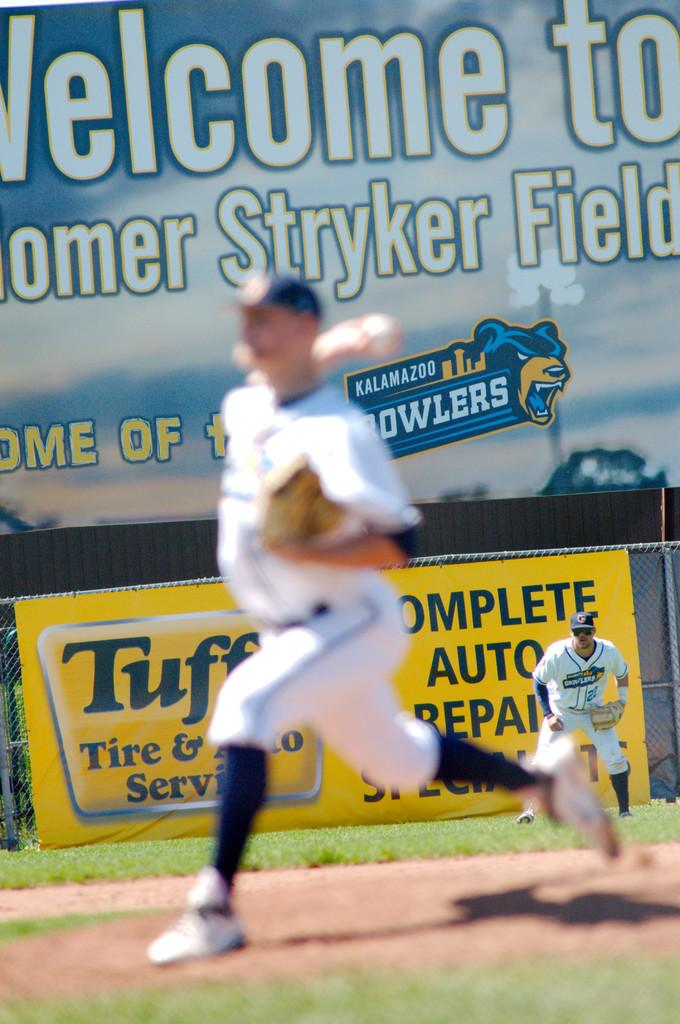<image>
Write a terse but informative summary of the picture. flyer for the kalamazoo howlers who play at homer stryker field and it shows fuzzy picture of a pitcher throwing 